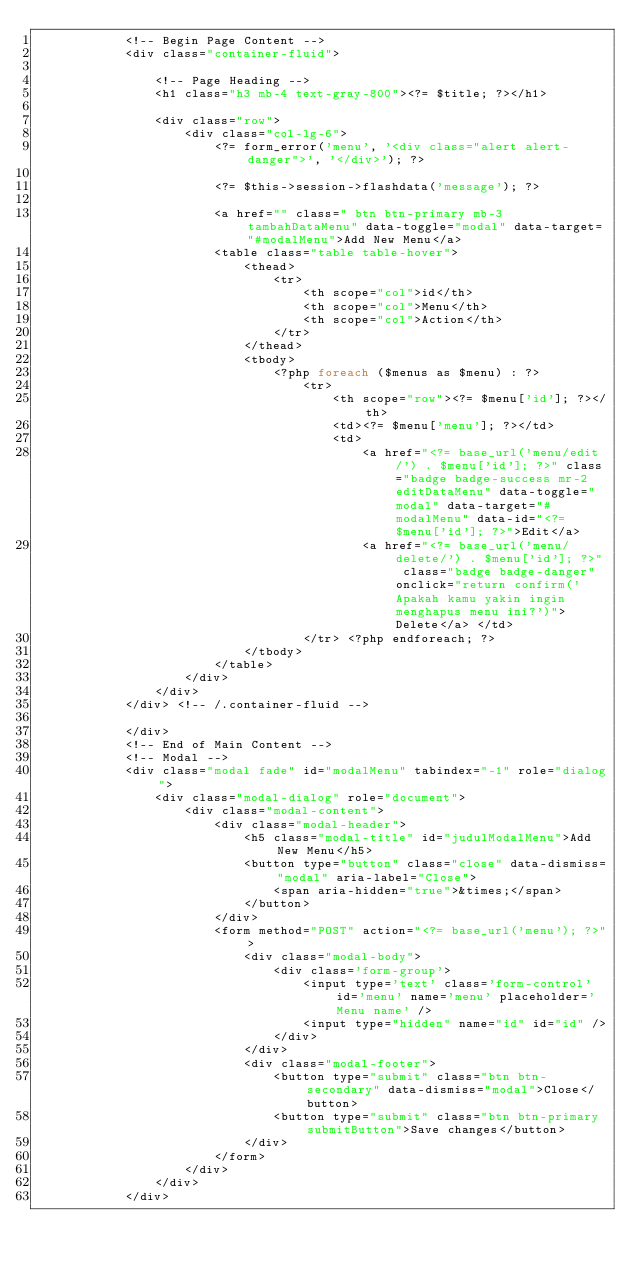<code> <loc_0><loc_0><loc_500><loc_500><_PHP_>			<!-- Begin Page Content -->
			<div class="container-fluid">

				<!-- Page Heading -->
				<h1 class="h3 mb-4 text-gray-800"><?= $title; ?></h1>

				<div class="row">
					<div class="col-lg-6">
						<?= form_error('menu', '<div class="alert alert-danger">', '</div>'); ?>

						<?= $this->session->flashdata('message'); ?>

						<a href="" class=" btn btn-primary mb-3 tambahDataMenu" data-toggle="modal" data-target="#modalMenu">Add New Menu</a>
						<table class="table table-hover">
							<thead>
								<tr>
									<th scope="col">id</th>
									<th scope="col">Menu</th>
									<th scope="col">Action</th>
								</tr>
							</thead>
							<tbody>
								<?php foreach ($menus as $menu) : ?>
									<tr>
										<th scope="row"><?= $menu['id']; ?></th>
										<td><?= $menu['menu']; ?></td>
										<td>
											<a href="<?= base_url('menu/edit/') . $menu['id']; ?>" class="badge badge-success mr-2 editDataMenu" data-toggle="modal" data-target="#modalMenu" data-id="<?= $menu['id']; ?>">Edit</a>
											<a href="<?= base_url('menu/delete/') . $menu['id']; ?>" class="badge badge-danger" onclick="return confirm('Apakah kamu yakin ingin menghapus menu ini?')">Delete</a> </td>
									</tr> <?php endforeach; ?>
							</tbody>
						</table>
					</div>
				</div>
			</div> <!-- /.container-fluid -->

			</div>
			<!-- End of Main Content -->
			<!-- Modal -->
			<div class="modal fade" id="modalMenu" tabindex="-1" role="dialog">
				<div class="modal-dialog" role="document">
					<div class="modal-content">
						<div class="modal-header">
							<h5 class="modal-title" id="judulModalMenu">Add New Menu</h5>
							<button type="button" class="close" data-dismiss="modal" aria-label="Close">
								<span aria-hidden="true">&times;</span>
							</button>
						</div>
						<form method="POST" action="<?= base_url('menu'); ?>">
							<div class="modal-body">
								<div class='form-group'>
									<input type='text' class='form-control' id='menu' name='menu' placeholder='Menu name' />
									<input type="hidden" name="id" id="id" />
								</div>
							</div>
							<div class="modal-footer">
								<button type="submit" class="btn btn-secondary" data-dismiss="modal">Close</button>
								<button type="submit" class="btn btn-primary submitButton">Save changes</button>
							</div>
						</form>
					</div>
				</div>
			</div>
</code> 